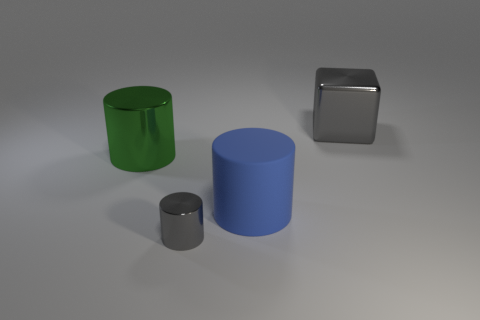What number of rubber things are either small yellow cylinders or cubes?
Keep it short and to the point. 0. Is the color of the rubber thing the same as the big cube?
Provide a short and direct response. No. Are there any other things of the same color as the tiny shiny cylinder?
Keep it short and to the point. Yes. Is the shape of the large object on the left side of the gray shiny cylinder the same as the big metal object to the right of the small gray metal thing?
Provide a short and direct response. No. What number of things are tiny cyan rubber blocks or cylinders that are behind the blue cylinder?
Keep it short and to the point. 1. What number of other things are there of the same size as the blue thing?
Offer a very short reply. 2. Do the large thing that is left of the blue object and the gray object that is in front of the blue rubber cylinder have the same material?
Offer a terse response. Yes. There is a blue matte thing; how many metallic things are in front of it?
Your answer should be compact. 1. How many green things are either large matte things or metal things?
Provide a succinct answer. 1. What is the material of the cube that is the same size as the blue rubber thing?
Offer a terse response. Metal. 